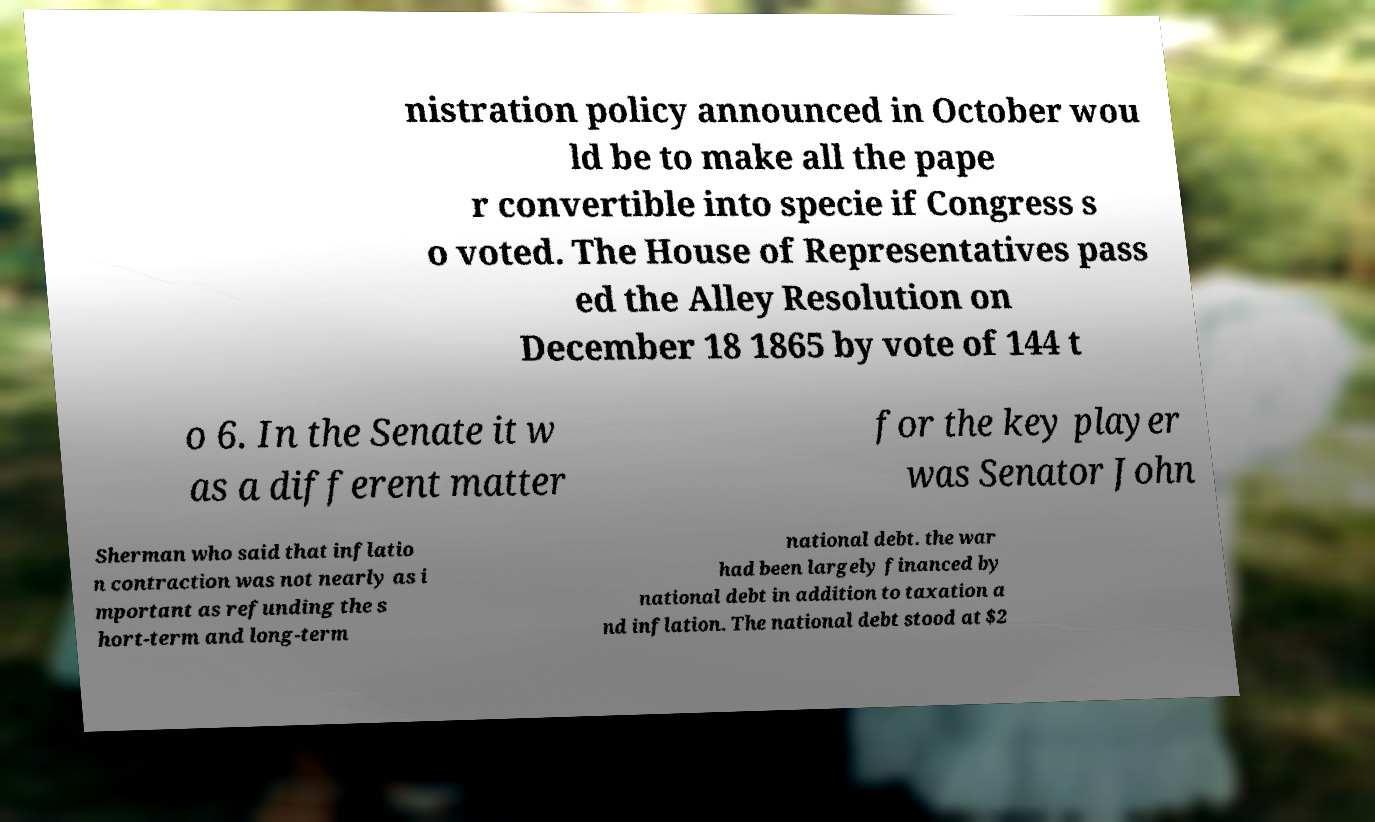Could you extract and type out the text from this image? nistration policy announced in October wou ld be to make all the pape r convertible into specie if Congress s o voted. The House of Representatives pass ed the Alley Resolution on December 18 1865 by vote of 144 t o 6. In the Senate it w as a different matter for the key player was Senator John Sherman who said that inflatio n contraction was not nearly as i mportant as refunding the s hort-term and long-term national debt. the war had been largely financed by national debt in addition to taxation a nd inflation. The national debt stood at $2 